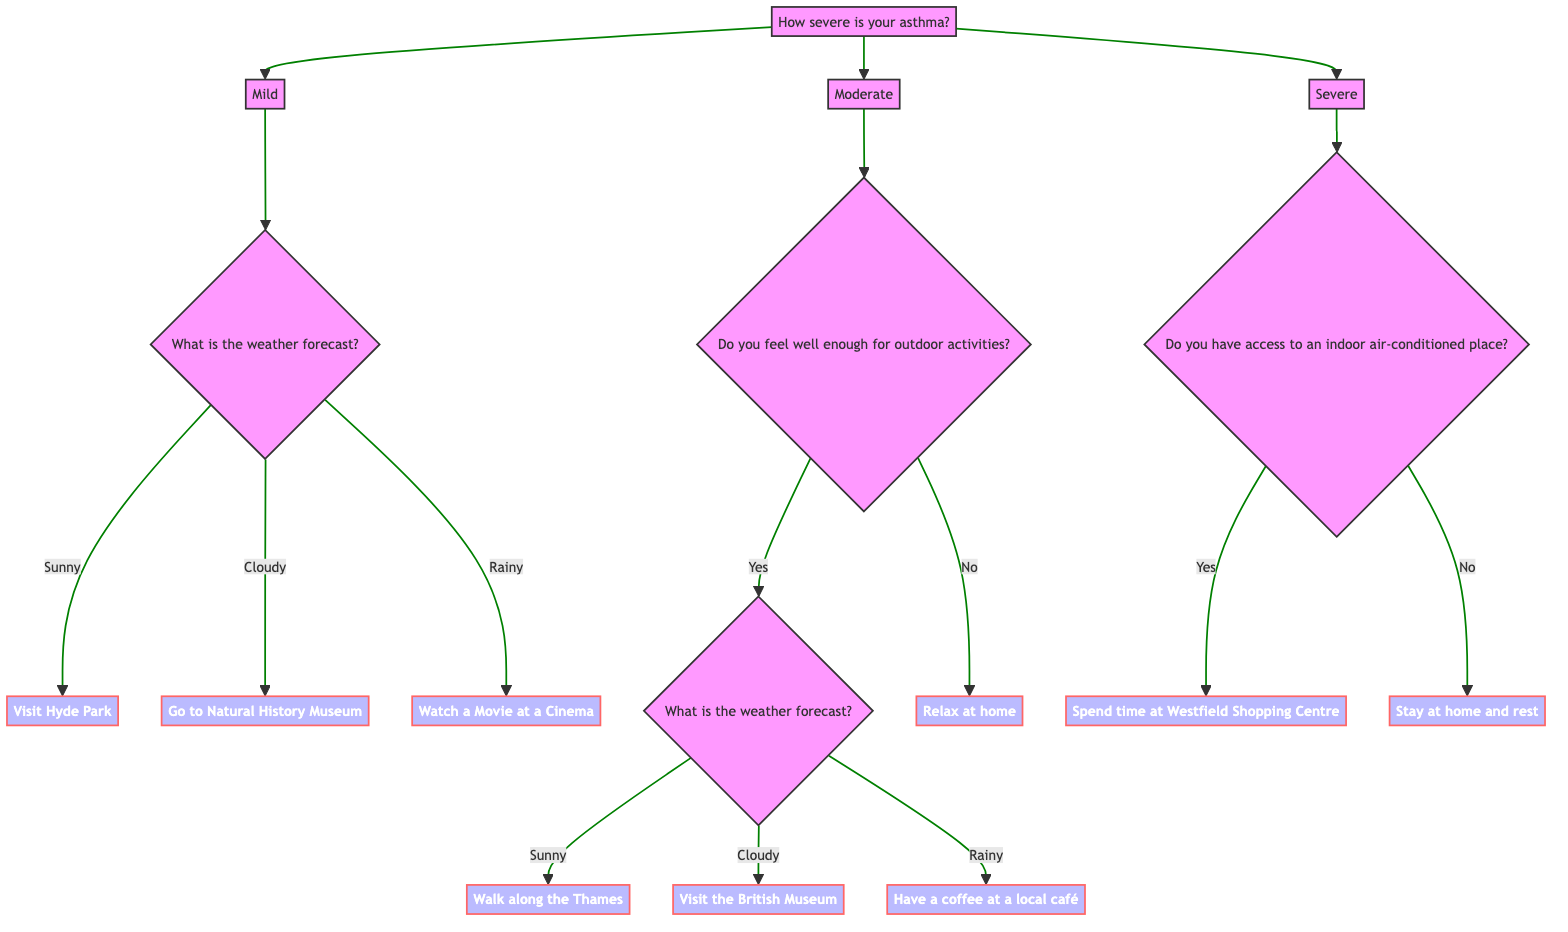How many main branches are there based on asthma severity? The main decision node "How severe is your asthma?" has three branches: Mild, Moderate, and Severe. This indicates that there are three main branches in the diagram, each corresponding to a different severity level of asthma.
Answer: 3 What activity is suggested if the weather is sunny and your asthma is moderate? Following the decision tree, if the asthma severity is moderate and the person feels well enough for outdoor activities, the next question is about the weather forecast. If the weather is sunny, the suggested activity is to walk along the Thames.
Answer: Walk along the Thames If the weather is rainy, what activities could you do if your asthma is mild? When the asthma is mild, the question about the weather forecast is posed. If the weather is rainy, the suggested activity is to watch a movie at a cinema, as that corresponds to the rainy condition under mild asthma.
Answer: Watch a Movie at a Cinema What happens if you have severe asthma but no access to an indoor air-conditioned place? With severe asthma, the next question is whether there is access to an indoor air-conditioned place. If the answer is no, the activity suggested by the tree is to stay at home and rest, which is indicated under that condition.
Answer: Stay at home and rest Which activity do you choose if you have mild asthma and it is cloudy? The decision tree specifies that if the asthma is mild and the weather forecast is cloudy, the activity chosen will be to go to the Natural History Museum. Thus, the activity correlates to the specific node structure for mild asthma and cloudy weather.
Answer: Go to Natural History Museum How does the decision tree categorize outdoor activity availability for moderate asthma? The decision tree indicates that for moderate asthma, there is an initial check on whether a person feels well enough for outdoor activities. If the answer is yes, it proceeds to another question about the weather forecast before suggesting an activity based on the result. If the answer is no, it suggests relaxing at home. This categorization is clear in the flow of the diagram.
Answer: Two possibilities (Yes or No) for outdoor activities 